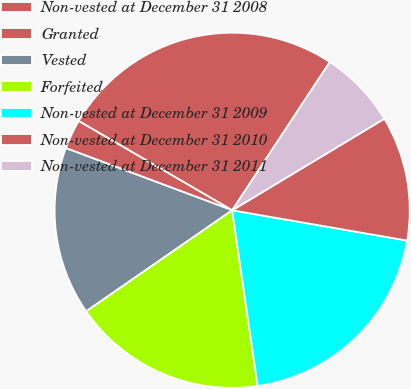Convert chart. <chart><loc_0><loc_0><loc_500><loc_500><pie_chart><fcel>Non-vested at December 31 2008<fcel>Granted<fcel>Vested<fcel>Forfeited<fcel>Non-vested at December 31 2009<fcel>Non-vested at December 31 2010<fcel>Non-vested at December 31 2011<nl><fcel>25.89%<fcel>2.69%<fcel>15.33%<fcel>17.66%<fcel>19.98%<fcel>11.35%<fcel>7.11%<nl></chart> 